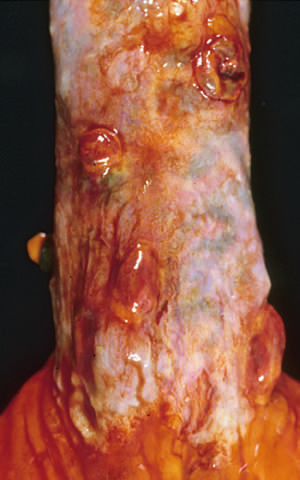re histoplasma capsulatum yeast forms present in this postmortem specimen corresponding to the angiogram in the figure?
Answer the question using a single word or phrase. No 